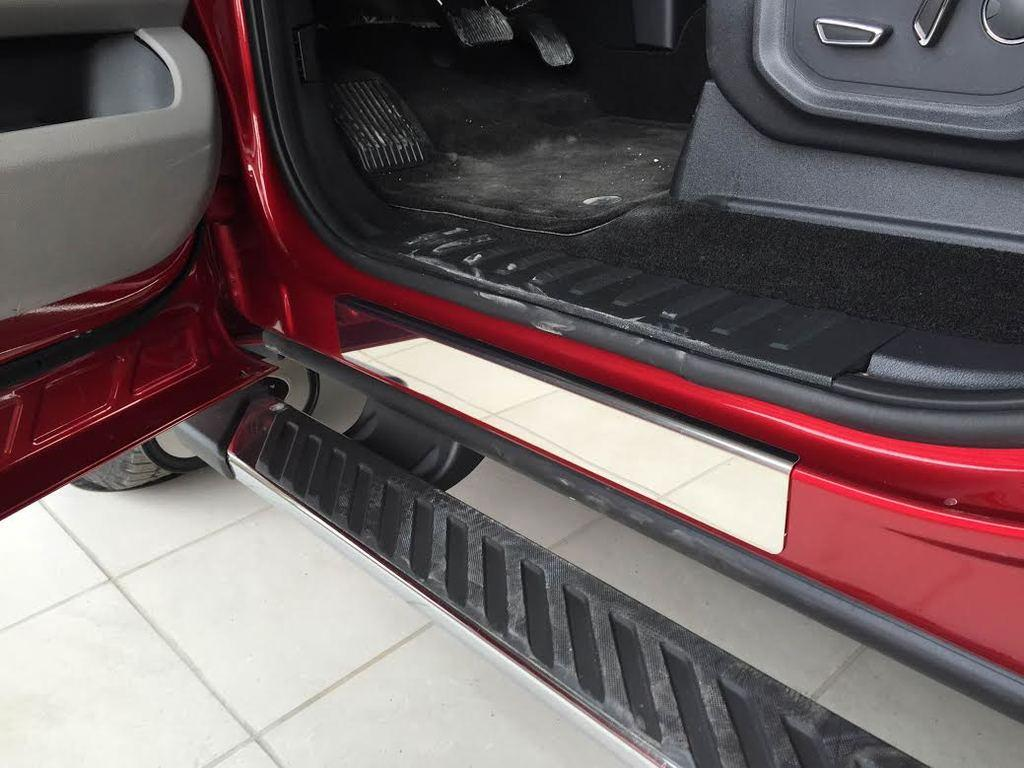What is the main subject of the image? There is a vehicle in the image. Can you describe the position of the vehicle in the image? The vehicle is on a surface. What type of church can be seen in the image? There is no church present in the image; it only features a vehicle on a surface. How many stitches are visible on the vehicle in the image? There are no stitches visible on the vehicle in the image, as it is not a fabric or textile object. 